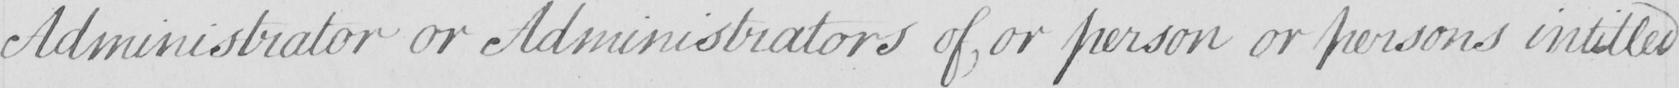Can you tell me what this handwritten text says? Administrator or Administrators of , or person or persons intitled 